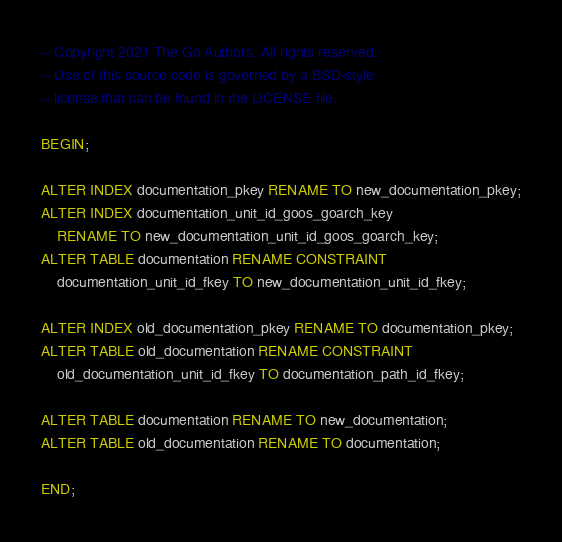<code> <loc_0><loc_0><loc_500><loc_500><_SQL_>-- Copyright 2021 The Go Authors. All rights reserved.
-- Use of this source code is governed by a BSD-style
-- license that can be found in the LICENSE file.

BEGIN;

ALTER INDEX documentation_pkey RENAME TO new_documentation_pkey;
ALTER INDEX documentation_unit_id_goos_goarch_key
    RENAME TO new_documentation_unit_id_goos_goarch_key;
ALTER TABLE documentation RENAME CONSTRAINT
    documentation_unit_id_fkey TO new_documentation_unit_id_fkey;

ALTER INDEX old_documentation_pkey RENAME TO documentation_pkey;
ALTER TABLE old_documentation RENAME CONSTRAINT
    old_documentation_unit_id_fkey TO documentation_path_id_fkey;

ALTER TABLE documentation RENAME TO new_documentation;
ALTER TABLE old_documentation RENAME TO documentation;

END;
</code> 